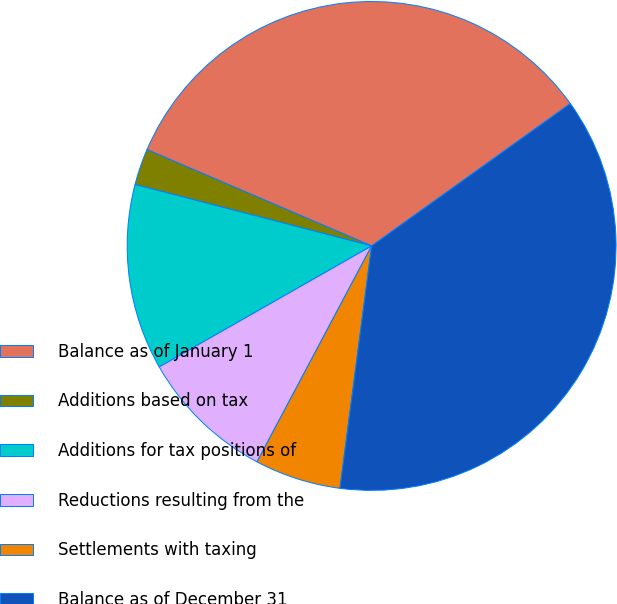Convert chart. <chart><loc_0><loc_0><loc_500><loc_500><pie_chart><fcel>Balance as of January 1<fcel>Additions based on tax<fcel>Additions for tax positions of<fcel>Reductions resulting from the<fcel>Settlements with taxing<fcel>Balance as of December 31<nl><fcel>33.66%<fcel>2.4%<fcel>12.29%<fcel>8.99%<fcel>5.7%<fcel>36.96%<nl></chart> 